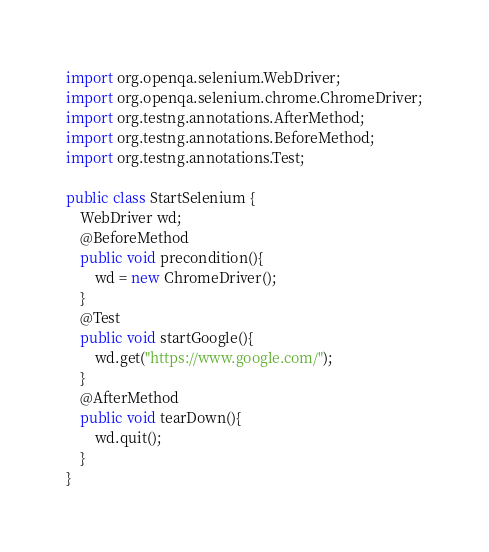<code> <loc_0><loc_0><loc_500><loc_500><_Java_>import org.openqa.selenium.WebDriver;
import org.openqa.selenium.chrome.ChromeDriver;
import org.testng.annotations.AfterMethod;
import org.testng.annotations.BeforeMethod;
import org.testng.annotations.Test;

public class StartSelenium {
    WebDriver wd;
    @BeforeMethod
    public void precondition(){
        wd = new ChromeDriver();
    }
    @Test
    public void startGoogle(){
        wd.get("https://www.google.com/");
    }
    @AfterMethod
    public void tearDown(){
        wd.quit();
    }
}
</code> 